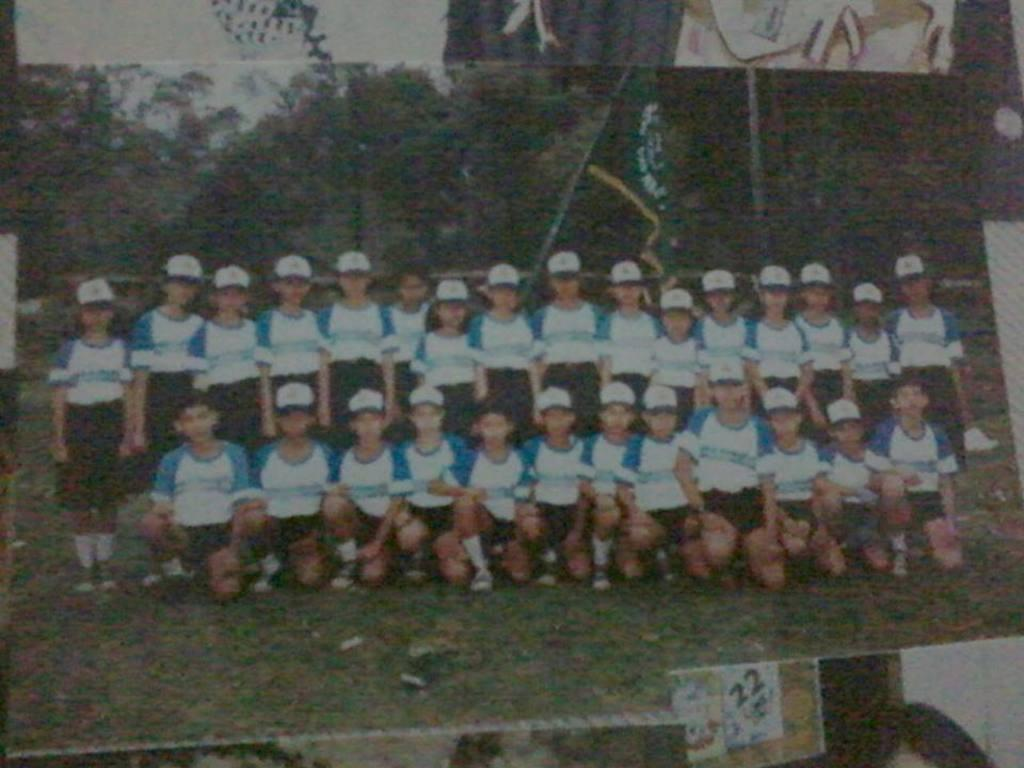What is the main subject of the image? The main subject of the image is a photo. What can be seen in the photo? There are people standing in the photo. How are some of the people positioned in the photo? Some people are laying on their knees in the photo. What type of decision can be seen being made in the photo? There is no decision being made in the photo; it is a still image of people standing and laying on their knees. 